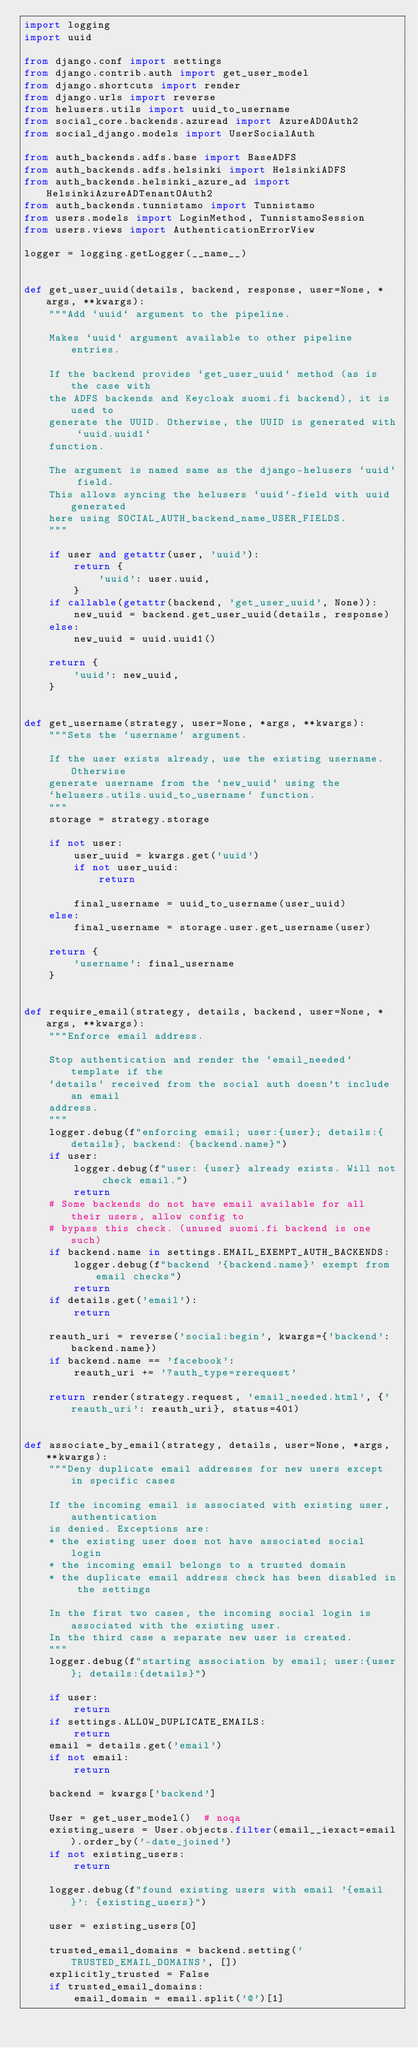<code> <loc_0><loc_0><loc_500><loc_500><_Python_>import logging
import uuid

from django.conf import settings
from django.contrib.auth import get_user_model
from django.shortcuts import render
from django.urls import reverse
from helusers.utils import uuid_to_username
from social_core.backends.azuread import AzureADOAuth2
from social_django.models import UserSocialAuth

from auth_backends.adfs.base import BaseADFS
from auth_backends.adfs.helsinki import HelsinkiADFS
from auth_backends.helsinki_azure_ad import HelsinkiAzureADTenantOAuth2
from auth_backends.tunnistamo import Tunnistamo
from users.models import LoginMethod, TunnistamoSession
from users.views import AuthenticationErrorView

logger = logging.getLogger(__name__)


def get_user_uuid(details, backend, response, user=None, *args, **kwargs):
    """Add `uuid` argument to the pipeline.

    Makes `uuid` argument available to other pipeline entries.

    If the backend provides `get_user_uuid` method (as is the case with
    the ADFS backends and Keycloak suomi.fi backend), it is used to
    generate the UUID. Otherwise, the UUID is generated with `uuid.uuid1`
    function.

    The argument is named same as the django-helusers `uuid` field.
    This allows syncing the helusers `uuid`-field with uuid generated
    here using SOCIAL_AUTH_backend_name_USER_FIELDS.
    """

    if user and getattr(user, 'uuid'):
        return {
            'uuid': user.uuid,
        }
    if callable(getattr(backend, 'get_user_uuid', None)):
        new_uuid = backend.get_user_uuid(details, response)
    else:
        new_uuid = uuid.uuid1()

    return {
        'uuid': new_uuid,
    }


def get_username(strategy, user=None, *args, **kwargs):
    """Sets the `username` argument.

    If the user exists already, use the existing username. Otherwise
    generate username from the `new_uuid` using the
    `helusers.utils.uuid_to_username` function.
    """
    storage = strategy.storage

    if not user:
        user_uuid = kwargs.get('uuid')
        if not user_uuid:
            return

        final_username = uuid_to_username(user_uuid)
    else:
        final_username = storage.user.get_username(user)

    return {
        'username': final_username
    }


def require_email(strategy, details, backend, user=None, *args, **kwargs):
    """Enforce email address.

    Stop authentication and render the `email_needed` template if the
    `details` received from the social auth doesn't include an email
    address.
    """
    logger.debug(f"enforcing email; user:{user}; details:{details}, backend: {backend.name}")
    if user:
        logger.debug(f"user: {user} already exists. Will not check email.")
        return
    # Some backends do not have email available for all their users, allow config to
    # bypass this check. (unused suomi.fi backend is one such)
    if backend.name in settings.EMAIL_EXEMPT_AUTH_BACKENDS:
        logger.debug(f"backend '{backend.name}' exempt from email checks")
        return
    if details.get('email'):
        return

    reauth_uri = reverse('social:begin', kwargs={'backend': backend.name})
    if backend.name == 'facebook':
        reauth_uri += '?auth_type=rerequest'

    return render(strategy.request, 'email_needed.html', {'reauth_uri': reauth_uri}, status=401)


def associate_by_email(strategy, details, user=None, *args, **kwargs):
    """Deny duplicate email addresses for new users except in specific cases

    If the incoming email is associated with existing user, authentication
    is denied. Exceptions are:
    * the existing user does not have associated social login
    * the incoming email belongs to a trusted domain
    * the duplicate email address check has been disabled in the settings

    In the first two cases, the incoming social login is associated with the existing user.
    In the third case a separate new user is created.
    """
    logger.debug(f"starting association by email; user:{user}; details:{details}")

    if user:
        return
    if settings.ALLOW_DUPLICATE_EMAILS:
        return
    email = details.get('email')
    if not email:
        return

    backend = kwargs['backend']

    User = get_user_model()  # noqa
    existing_users = User.objects.filter(email__iexact=email).order_by('-date_joined')
    if not existing_users:
        return

    logger.debug(f"found existing users with email '{email}': {existing_users}")

    user = existing_users[0]

    trusted_email_domains = backend.setting('TRUSTED_EMAIL_DOMAINS', [])
    explicitly_trusted = False
    if trusted_email_domains:
        email_domain = email.split('@')[1]</code> 